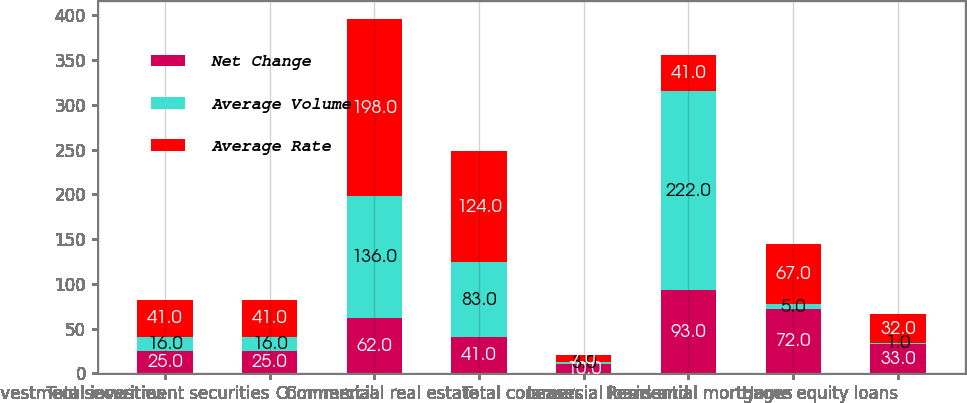<chart> <loc_0><loc_0><loc_500><loc_500><stacked_bar_chart><ecel><fcel>Taxable investment securities<fcel>Total investment securities<fcel>Commercial<fcel>Commercial real estate<fcel>Leases<fcel>Total commercial loans and<fcel>Residential mortgages<fcel>Home equity loans<nl><fcel>Net Change<fcel>25<fcel>25<fcel>62<fcel>41<fcel>10<fcel>93<fcel>72<fcel>33<nl><fcel>Average Volume<fcel>16<fcel>16<fcel>136<fcel>83<fcel>3<fcel>222<fcel>5<fcel>1<nl><fcel>Average Rate<fcel>41<fcel>41<fcel>198<fcel>124<fcel>7<fcel>41<fcel>67<fcel>32<nl></chart> 